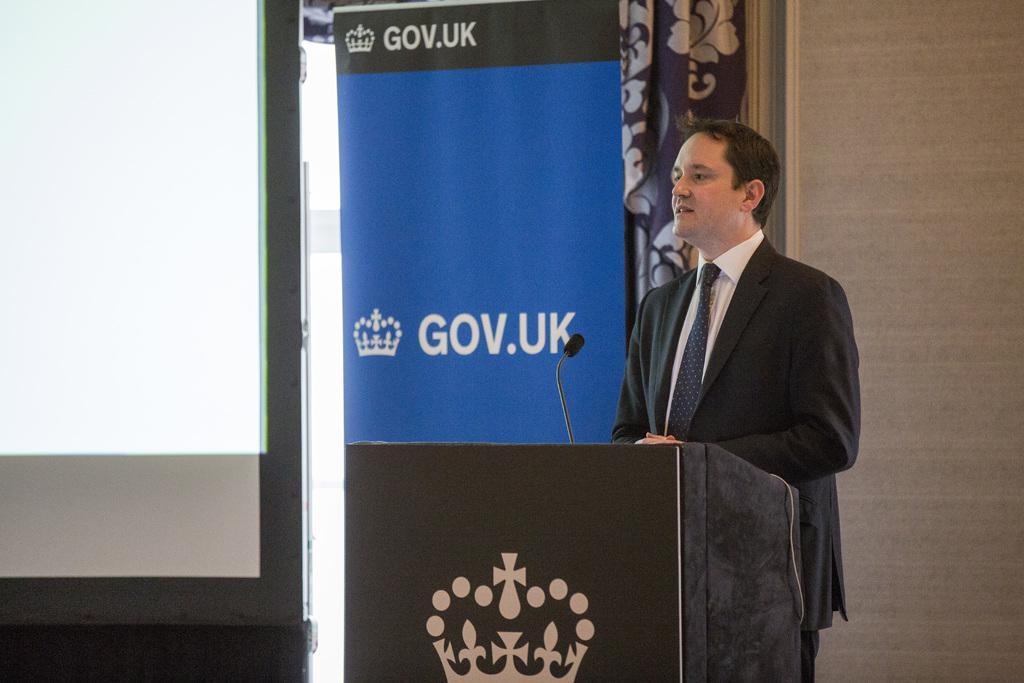Can you describe this image briefly? In this image we can see a man standing at the podium and a mic is attached to it. In the background there are curtains and a display screen. 